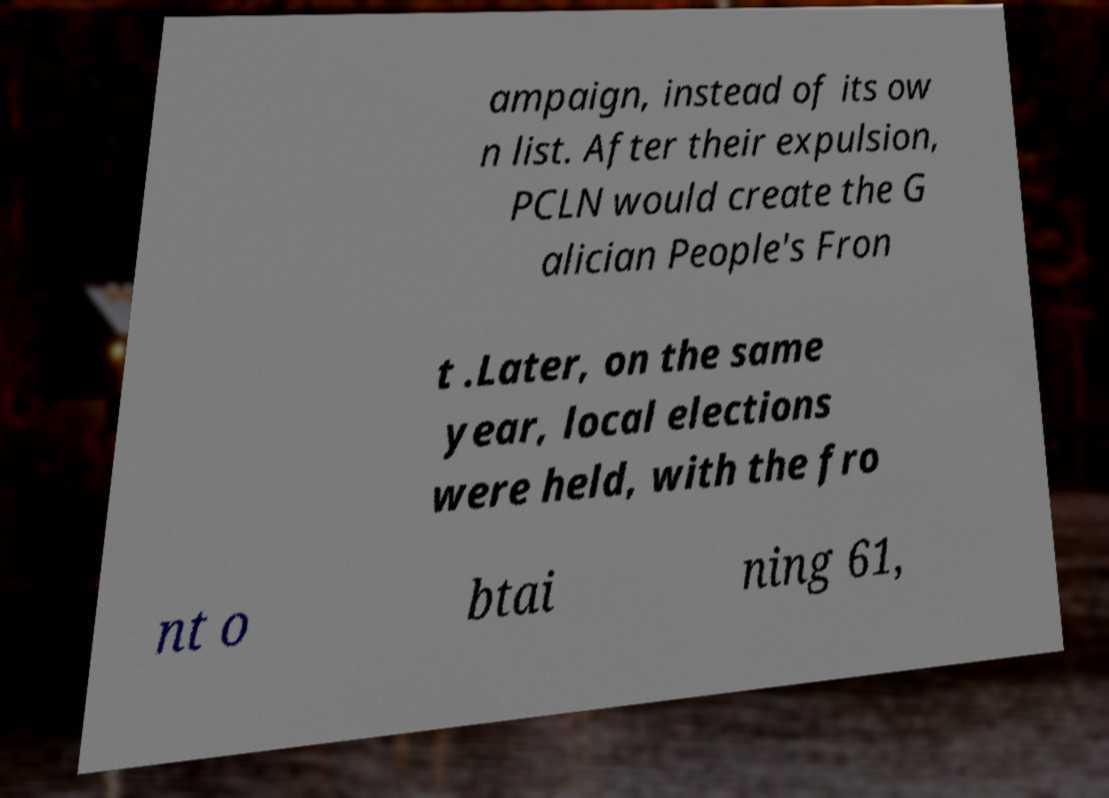Please identify and transcribe the text found in this image. ampaign, instead of its ow n list. After their expulsion, PCLN would create the G alician People's Fron t .Later, on the same year, local elections were held, with the fro nt o btai ning 61, 